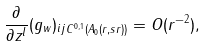<formula> <loc_0><loc_0><loc_500><loc_500>\| \frac { \partial } { \partial z ^ { l } } ( g _ { w } ) _ { i j } \| _ { C ^ { 0 , 1 } ( A _ { 0 } ( r , s r ) ) } = O ( r ^ { - 2 } ) ,</formula> 